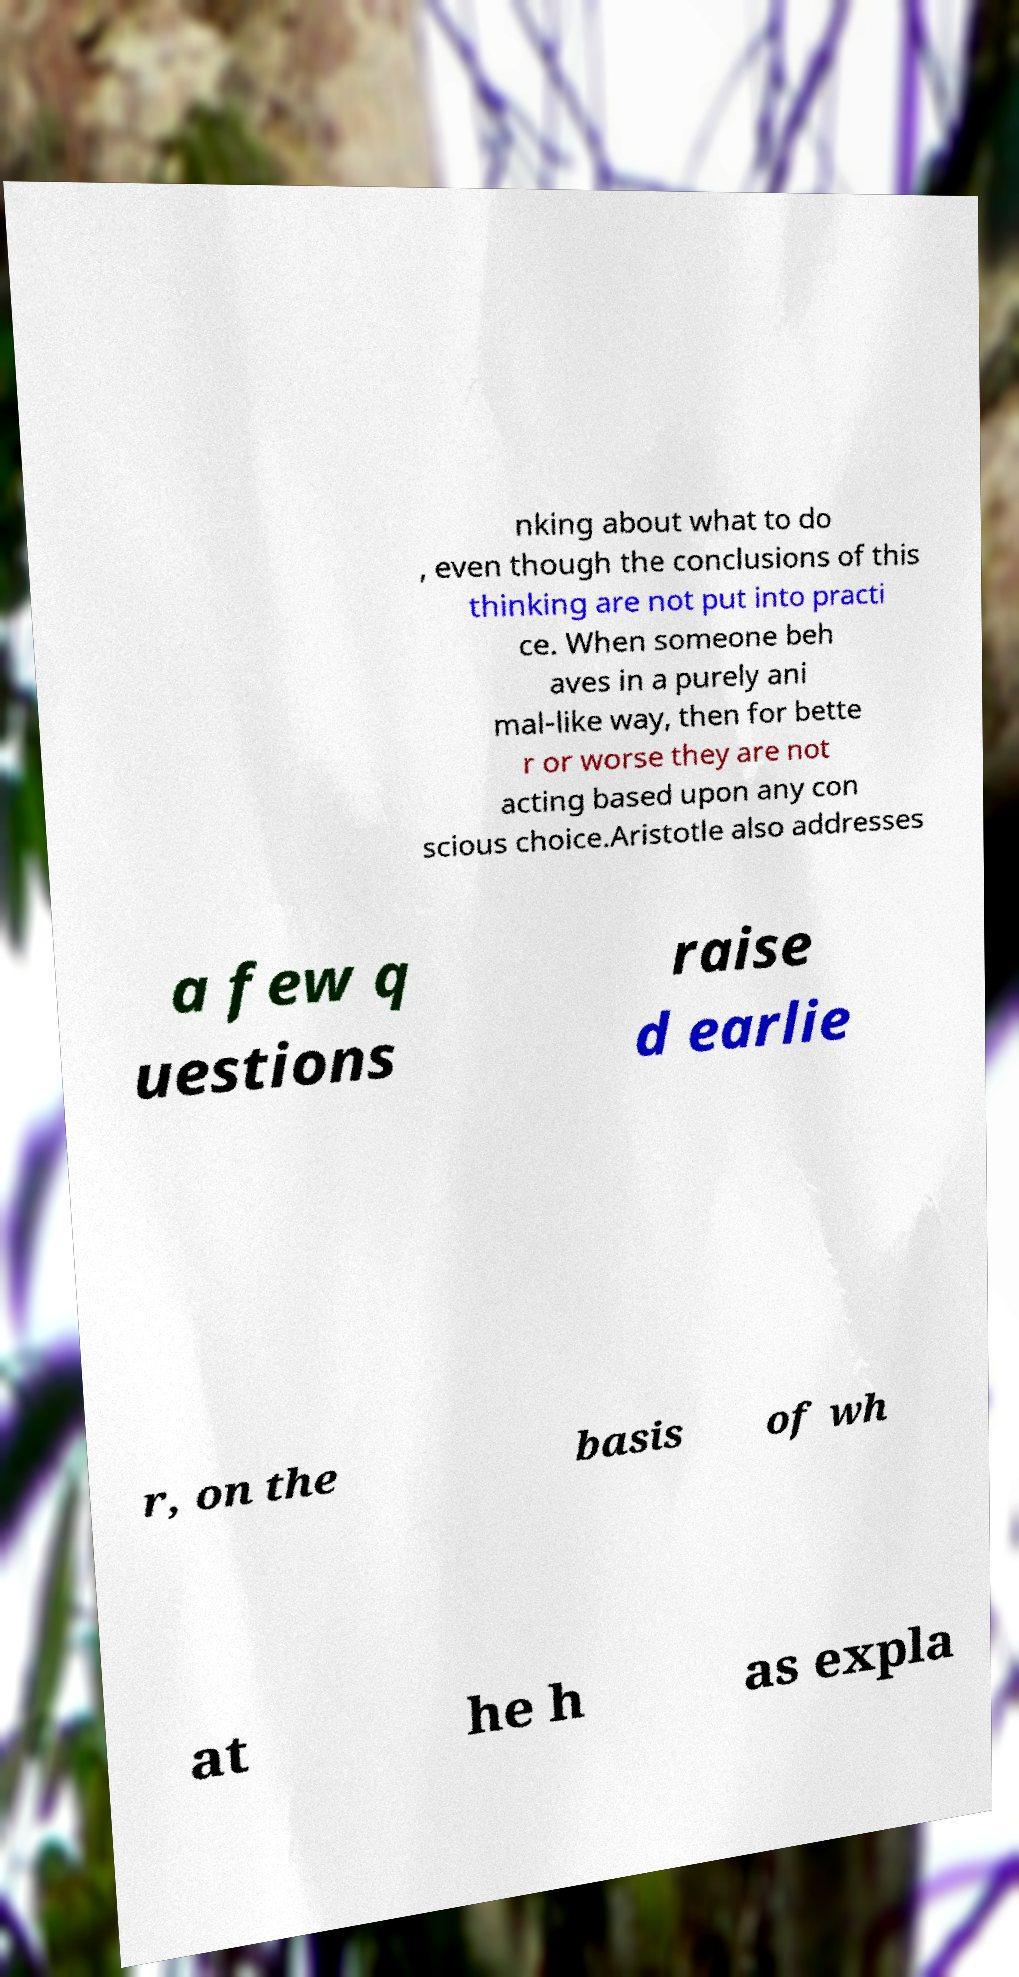Please identify and transcribe the text found in this image. nking about what to do , even though the conclusions of this thinking are not put into practi ce. When someone beh aves in a purely ani mal-like way, then for bette r or worse they are not acting based upon any con scious choice.Aristotle also addresses a few q uestions raise d earlie r, on the basis of wh at he h as expla 